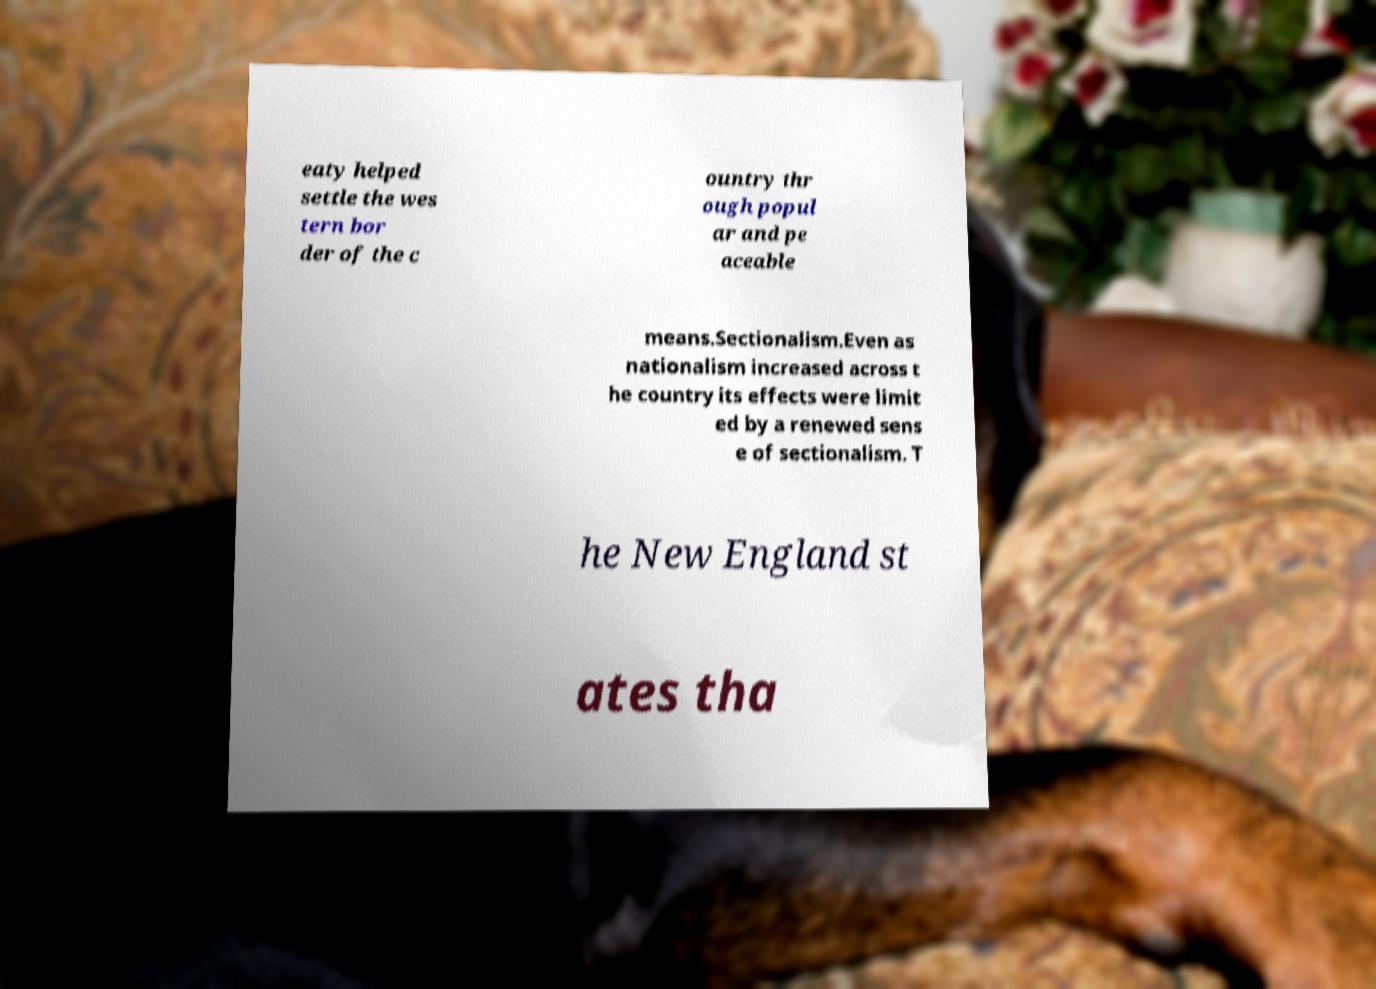Could you assist in decoding the text presented in this image and type it out clearly? eaty helped settle the wes tern bor der of the c ountry thr ough popul ar and pe aceable means.Sectionalism.Even as nationalism increased across t he country its effects were limit ed by a renewed sens e of sectionalism. T he New England st ates tha 